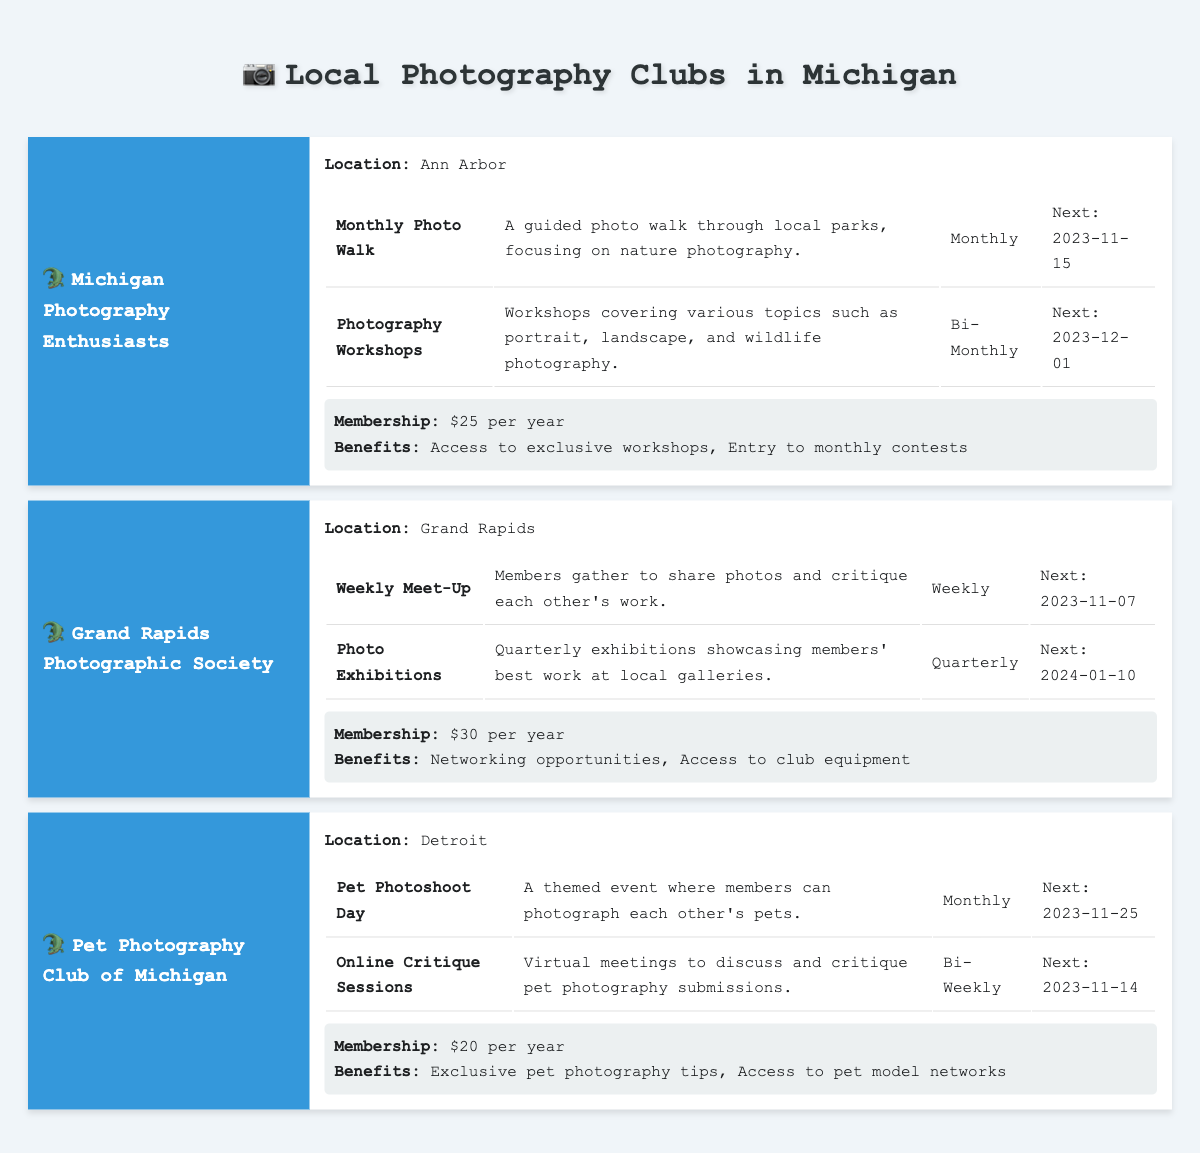What is the next event date for the "Pet Photoshoot Day"? The "Pet Photoshoot Day" is listed under the activities for the "Pet Photography Club of Michigan," and its next event date is provided as "2023-11-25."
Answer: 2023-11-25 What is the membership fee for the "Grand Rapids Photographic Society"? The membership fee for the "Grand Rapids Photographic Society" is indicated as "$30 per year" in the membership section of the table.
Answer: $30 per year Which club has a monthly activity that focuses on nature photography? The "Michigan Photography Enthusiasts" club has a monthly activity called "Monthly Photo Walk" that focuses on nature photography. It is explicitly mentioned in the activities section.
Answer: Michigan Photography Enthusiasts How many clubs have a next event in November 2023? To find this, we check the next event dates for each club's activities. "Michigan Photography Enthusiasts" has one on "2023-11-15," "Grand Rapids Photographic Society" has "2023-11-07," and "Pet Photography Club of Michigan" has "2023-11-25." Therefore, a total of three clubs have events in November 2023.
Answer: 3 Is there a club that meets weekly? Yes, the "Grand Rapids Photographic Society" has a weekly meet-up, as stated in its activities section.
Answer: Yes What benefits do members of the "Pet Photography Club of Michigan" receive? The benefits for the "Pet Photography Club of Michigan" members, as listed, are "Exclusive pet photography tips" and "Access to pet model networks."
Answer: Exclusive pet photography tips, Access to pet model networks Which club has its next event on December 1, 2023? The "Michigan Photography Enthusiasts" has its next event, the "Photography Workshops," scheduled for December 1, 2023. This can be confirmed by checking the next event dates listed for this club.
Answer: Michigan Photography Enthusiasts How many total benefits are listed for the "Michigan Photography Enthusiasts"? The "Michigan Photography Enthusiasts" has two benefits listed: "Access to exclusive workshops" and "Entry to monthly contests," which can be counted from the benefits section.
Answer: 2 What is the main focus of the activity "Online Critique Sessions"? The "Online Critique Sessions" for the "Pet Photography Club of Michigan" focus on discussing and critiquing pet photography submissions. This can be obtained directly from the description of the activity within the table.
Answer: Discussing and critiquing pet photography submissions 